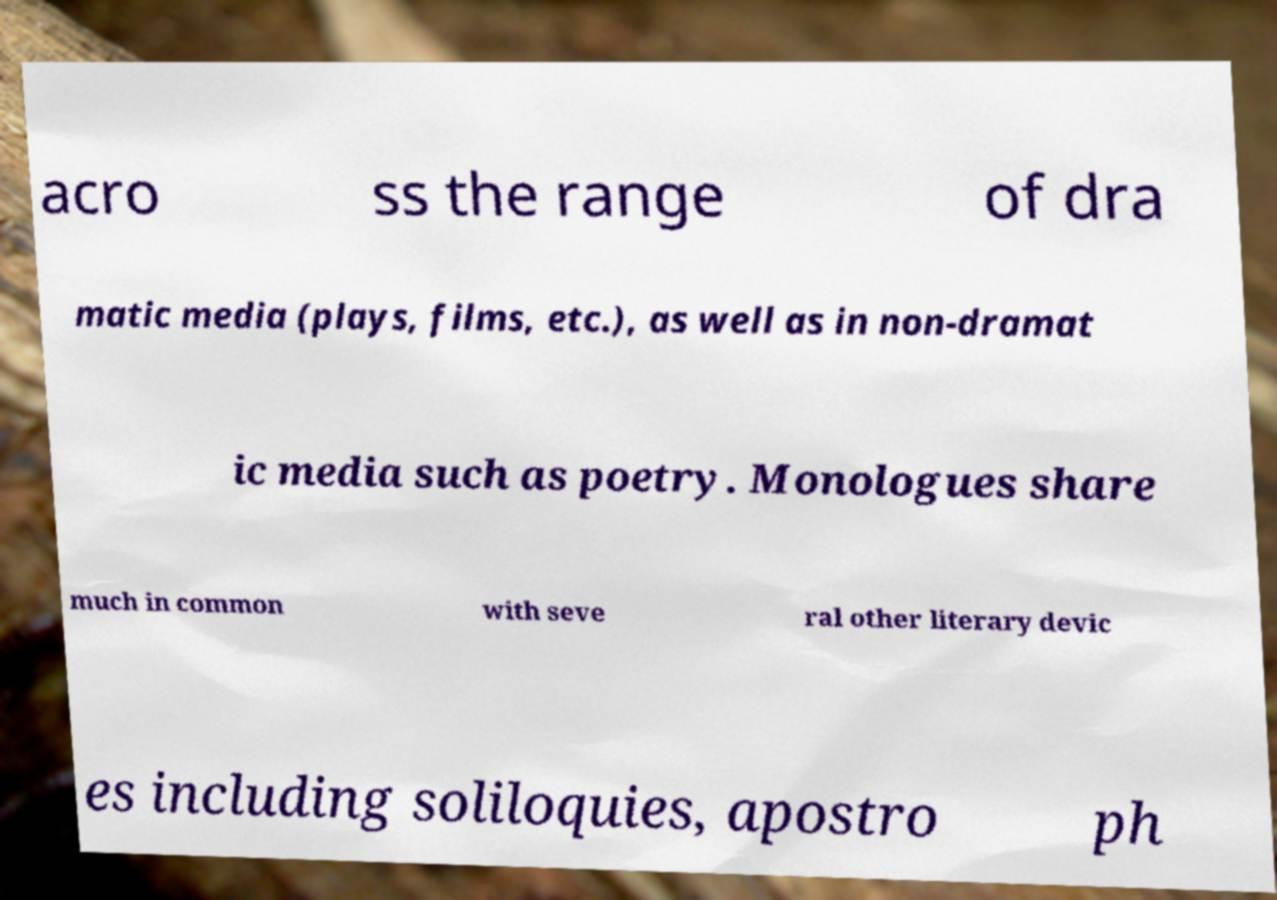Could you extract and type out the text from this image? acro ss the range of dra matic media (plays, films, etc.), as well as in non-dramat ic media such as poetry. Monologues share much in common with seve ral other literary devic es including soliloquies, apostro ph 